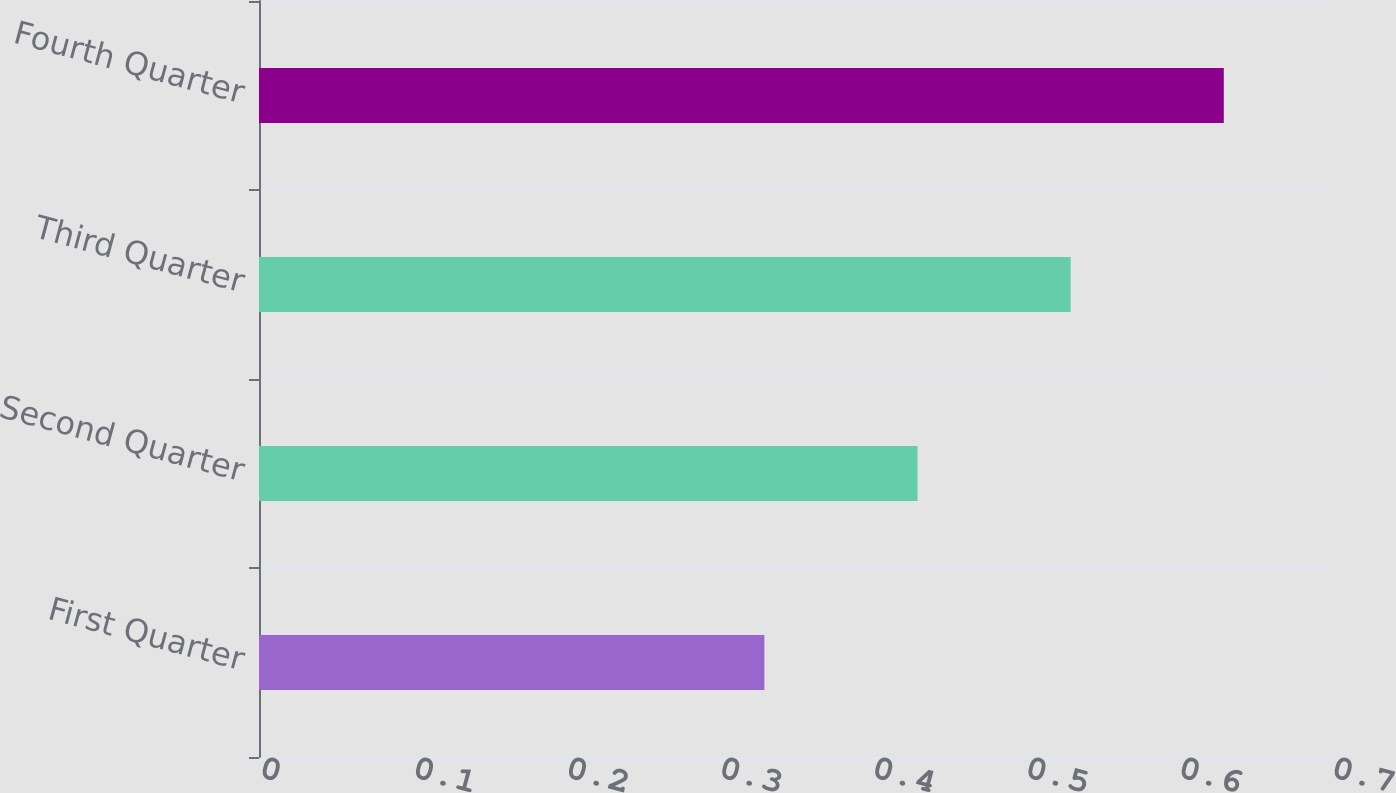Convert chart. <chart><loc_0><loc_0><loc_500><loc_500><bar_chart><fcel>First Quarter<fcel>Second Quarter<fcel>Third Quarter<fcel>Fourth Quarter<nl><fcel>0.33<fcel>0.43<fcel>0.53<fcel>0.63<nl></chart> 